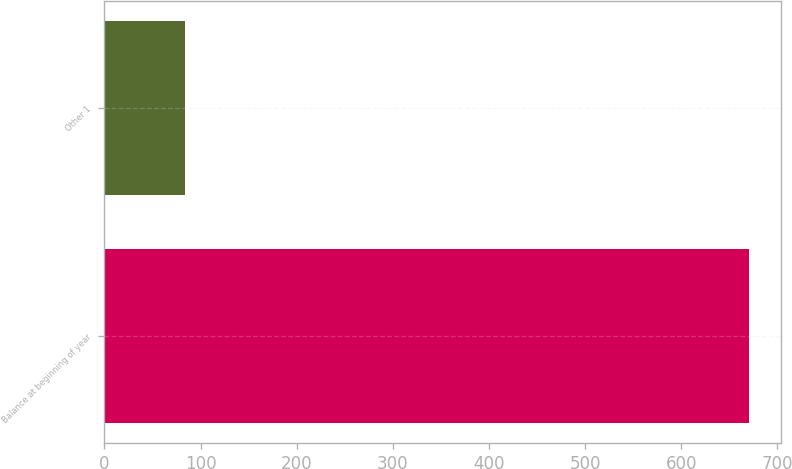Convert chart to OTSL. <chart><loc_0><loc_0><loc_500><loc_500><bar_chart><fcel>Balance at beginning of year<fcel>Other 1<nl><fcel>670<fcel>84<nl></chart> 